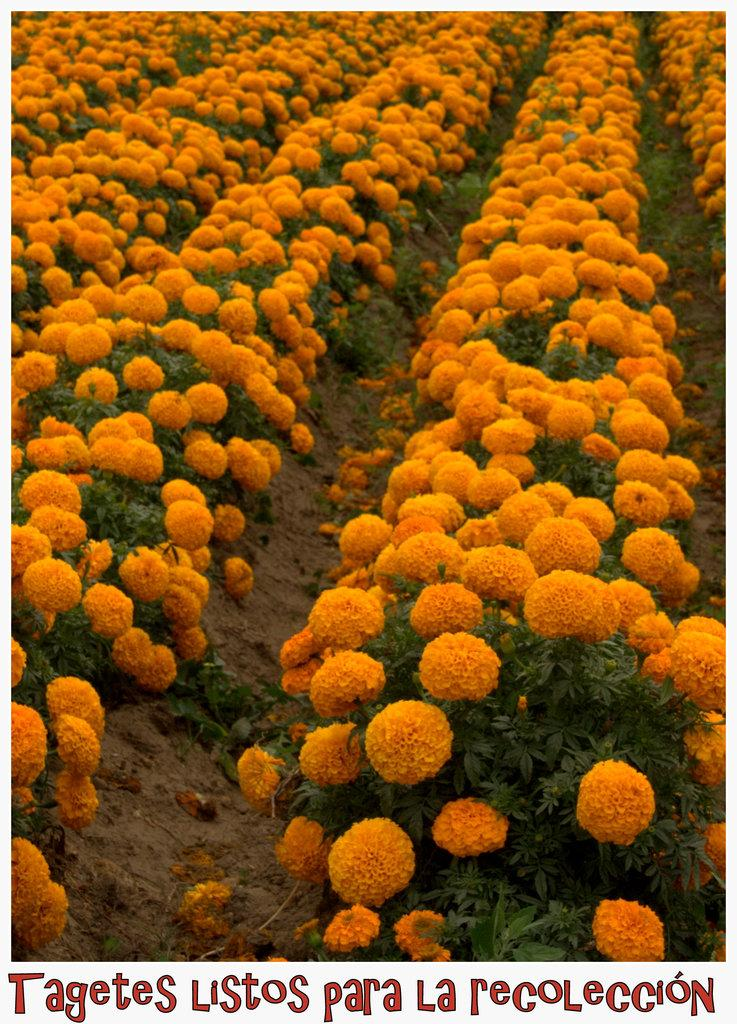What type of garden is shown in the image? There is a flower garden in the image. How many plants can be seen in the flower garden? There are many plants in the flower garden. What feature do the plants in the garden have? The plants in the garden have flowers. What is the opinion of the plants about the weather in the image? There is no indication of the plants' opinions in the image, as plants do not have the ability to express opinions. 